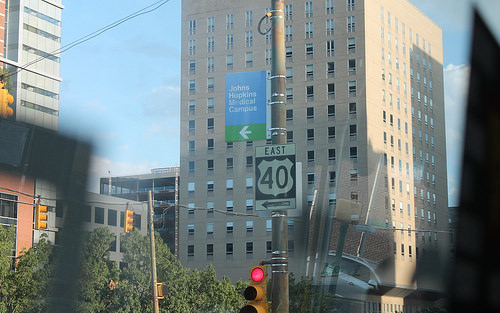<image>
Is there a sign on the building? No. The sign is not positioned on the building. They may be near each other, but the sign is not supported by or resting on top of the building. 